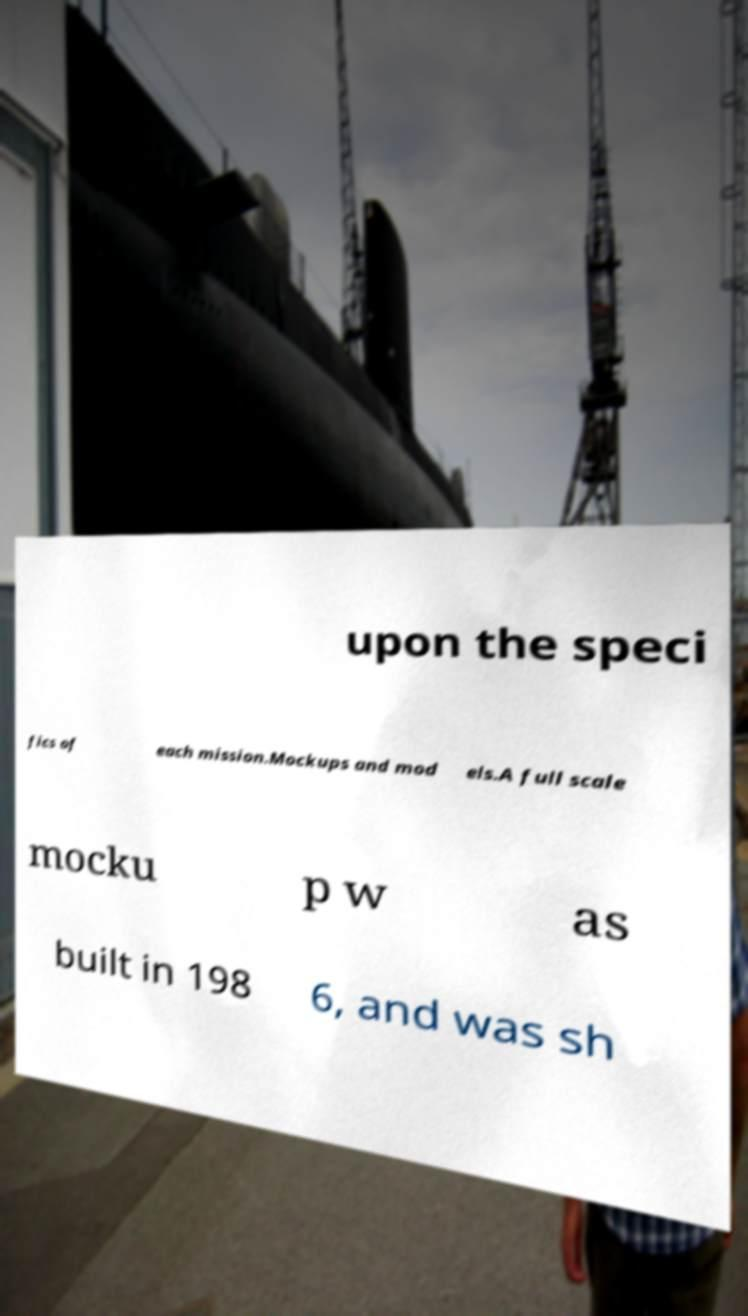For documentation purposes, I need the text within this image transcribed. Could you provide that? upon the speci fics of each mission.Mockups and mod els.A full scale mocku p w as built in 198 6, and was sh 